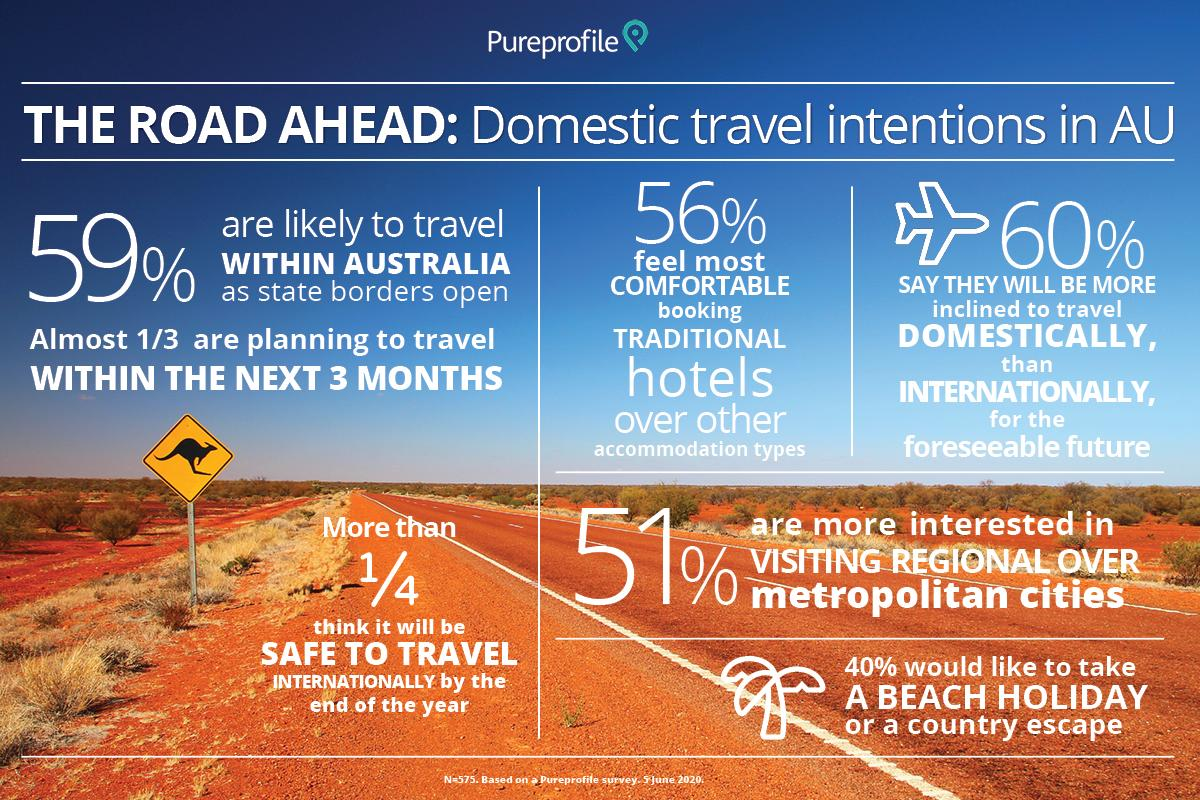Draw attention to some important aspects in this diagram. Approximately 25% of respondents believe it will be safe to travel internationally by the end of the year. According to a survey, 40% of people would not be inclined to travel domestically. 